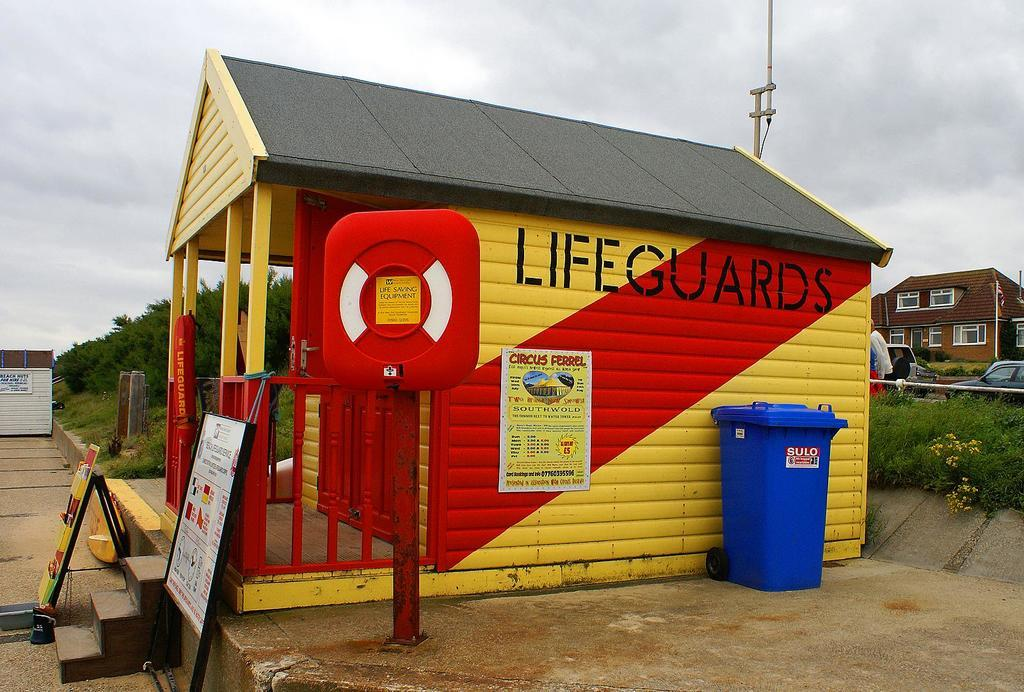<image>
Summarize the visual content of the image. A lifeguards' shack has a red diagonal stripe on the side. 